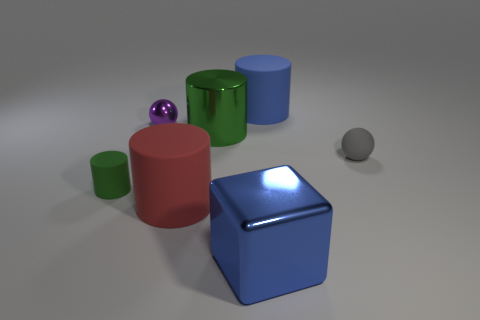Are the red cylinder and the cylinder that is to the right of the big green object made of the same material?
Provide a short and direct response. Yes. Is there a blue metal thing?
Your response must be concise. Yes. Are there any purple metallic balls behind the big blue object that is behind the sphere that is on the right side of the blue cylinder?
Your answer should be very brief. No. How many large objects are rubber cylinders or gray rubber things?
Make the answer very short. 2. There is a rubber cylinder that is the same size as the purple ball; what is its color?
Offer a very short reply. Green. What number of big cubes are on the right side of the large cube?
Provide a short and direct response. 0. Is there a cyan block that has the same material as the purple sphere?
Ensure brevity in your answer.  No. The big thing that is the same color as the cube is what shape?
Keep it short and to the point. Cylinder. What is the color of the tiny sphere to the right of the big block?
Your answer should be very brief. Gray. Are there an equal number of red rubber objects behind the gray sphere and large blue cubes that are left of the large blue matte cylinder?
Ensure brevity in your answer.  No. 